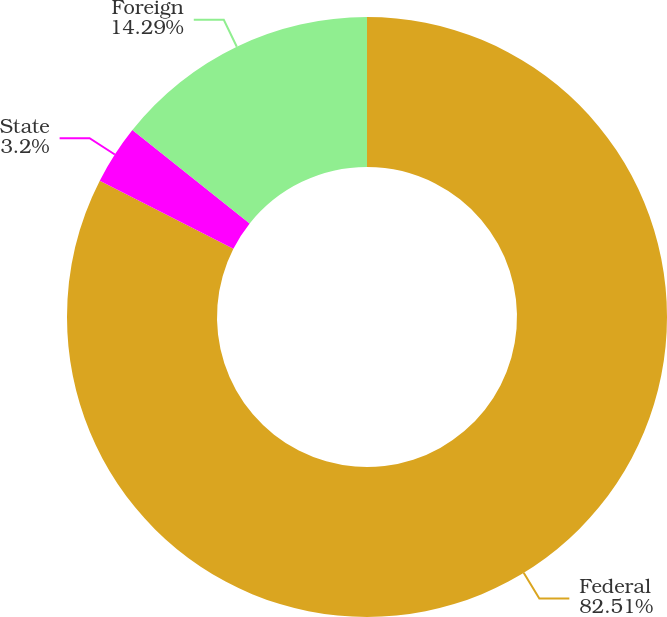<chart> <loc_0><loc_0><loc_500><loc_500><pie_chart><fcel>Federal<fcel>State<fcel>Foreign<nl><fcel>82.51%<fcel>3.2%<fcel>14.29%<nl></chart> 